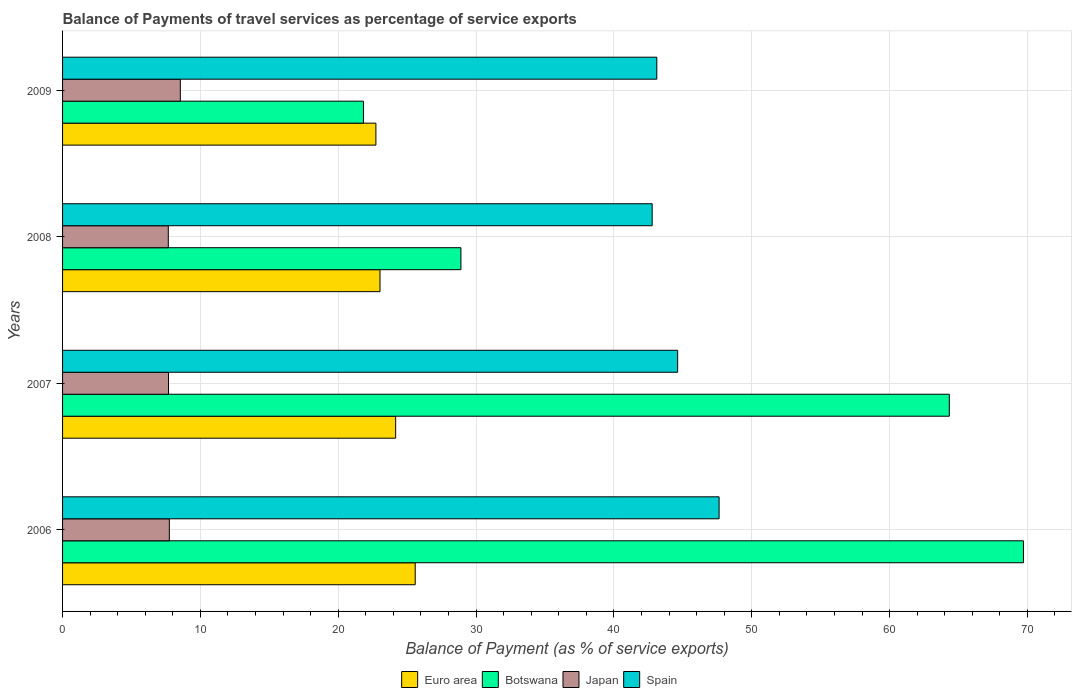How many different coloured bars are there?
Offer a very short reply. 4. Are the number of bars per tick equal to the number of legend labels?
Make the answer very short. Yes. Are the number of bars on each tick of the Y-axis equal?
Offer a very short reply. Yes. What is the label of the 2nd group of bars from the top?
Ensure brevity in your answer.  2008. What is the balance of payments of travel services in Spain in 2007?
Your answer should be very brief. 44.62. Across all years, what is the maximum balance of payments of travel services in Botswana?
Ensure brevity in your answer.  69.71. Across all years, what is the minimum balance of payments of travel services in Spain?
Offer a terse response. 42.78. In which year was the balance of payments of travel services in Spain minimum?
Provide a succinct answer. 2008. What is the total balance of payments of travel services in Euro area in the graph?
Provide a succinct answer. 95.51. What is the difference between the balance of payments of travel services in Spain in 2006 and that in 2009?
Provide a succinct answer. 4.52. What is the difference between the balance of payments of travel services in Japan in 2006 and the balance of payments of travel services in Euro area in 2009?
Make the answer very short. -14.99. What is the average balance of payments of travel services in Japan per year?
Ensure brevity in your answer.  7.91. In the year 2007, what is the difference between the balance of payments of travel services in Spain and balance of payments of travel services in Botswana?
Give a very brief answer. -19.71. In how many years, is the balance of payments of travel services in Spain greater than 58 %?
Keep it short and to the point. 0. What is the ratio of the balance of payments of travel services in Japan in 2006 to that in 2009?
Keep it short and to the point. 0.91. Is the balance of payments of travel services in Botswana in 2007 less than that in 2009?
Offer a terse response. No. What is the difference between the highest and the second highest balance of payments of travel services in Euro area?
Keep it short and to the point. 1.42. What is the difference between the highest and the lowest balance of payments of travel services in Botswana?
Keep it short and to the point. 47.88. In how many years, is the balance of payments of travel services in Spain greater than the average balance of payments of travel services in Spain taken over all years?
Keep it short and to the point. 2. Is the sum of the balance of payments of travel services in Japan in 2008 and 2009 greater than the maximum balance of payments of travel services in Euro area across all years?
Keep it short and to the point. No. What does the 2nd bar from the top in 2009 represents?
Provide a succinct answer. Japan. Is it the case that in every year, the sum of the balance of payments of travel services in Euro area and balance of payments of travel services in Japan is greater than the balance of payments of travel services in Spain?
Give a very brief answer. No. What is the difference between two consecutive major ticks on the X-axis?
Provide a succinct answer. 10. Are the values on the major ticks of X-axis written in scientific E-notation?
Make the answer very short. No. Does the graph contain any zero values?
Provide a short and direct response. No. Does the graph contain grids?
Offer a very short reply. Yes. How many legend labels are there?
Make the answer very short. 4. What is the title of the graph?
Make the answer very short. Balance of Payments of travel services as percentage of service exports. What is the label or title of the X-axis?
Give a very brief answer. Balance of Payment (as % of service exports). What is the Balance of Payment (as % of service exports) of Euro area in 2006?
Your response must be concise. 25.58. What is the Balance of Payment (as % of service exports) of Botswana in 2006?
Give a very brief answer. 69.71. What is the Balance of Payment (as % of service exports) in Japan in 2006?
Ensure brevity in your answer.  7.75. What is the Balance of Payment (as % of service exports) in Spain in 2006?
Offer a terse response. 47.63. What is the Balance of Payment (as % of service exports) of Euro area in 2007?
Offer a terse response. 24.17. What is the Balance of Payment (as % of service exports) in Botswana in 2007?
Ensure brevity in your answer.  64.33. What is the Balance of Payment (as % of service exports) in Japan in 2007?
Keep it short and to the point. 7.69. What is the Balance of Payment (as % of service exports) in Spain in 2007?
Your response must be concise. 44.62. What is the Balance of Payment (as % of service exports) of Euro area in 2008?
Your response must be concise. 23.03. What is the Balance of Payment (as % of service exports) of Botswana in 2008?
Give a very brief answer. 28.9. What is the Balance of Payment (as % of service exports) of Japan in 2008?
Your response must be concise. 7.67. What is the Balance of Payment (as % of service exports) in Spain in 2008?
Keep it short and to the point. 42.78. What is the Balance of Payment (as % of service exports) in Euro area in 2009?
Give a very brief answer. 22.73. What is the Balance of Payment (as % of service exports) of Botswana in 2009?
Your answer should be compact. 21.83. What is the Balance of Payment (as % of service exports) of Japan in 2009?
Ensure brevity in your answer.  8.54. What is the Balance of Payment (as % of service exports) in Spain in 2009?
Provide a succinct answer. 43.11. Across all years, what is the maximum Balance of Payment (as % of service exports) of Euro area?
Ensure brevity in your answer.  25.58. Across all years, what is the maximum Balance of Payment (as % of service exports) of Botswana?
Offer a terse response. 69.71. Across all years, what is the maximum Balance of Payment (as % of service exports) in Japan?
Keep it short and to the point. 8.54. Across all years, what is the maximum Balance of Payment (as % of service exports) in Spain?
Provide a succinct answer. 47.63. Across all years, what is the minimum Balance of Payment (as % of service exports) of Euro area?
Ensure brevity in your answer.  22.73. Across all years, what is the minimum Balance of Payment (as % of service exports) of Botswana?
Make the answer very short. 21.83. Across all years, what is the minimum Balance of Payment (as % of service exports) in Japan?
Make the answer very short. 7.67. Across all years, what is the minimum Balance of Payment (as % of service exports) in Spain?
Your answer should be compact. 42.78. What is the total Balance of Payment (as % of service exports) in Euro area in the graph?
Provide a succinct answer. 95.51. What is the total Balance of Payment (as % of service exports) in Botswana in the graph?
Your answer should be very brief. 184.78. What is the total Balance of Payment (as % of service exports) of Japan in the graph?
Make the answer very short. 31.65. What is the total Balance of Payment (as % of service exports) in Spain in the graph?
Give a very brief answer. 178.14. What is the difference between the Balance of Payment (as % of service exports) in Euro area in 2006 and that in 2007?
Keep it short and to the point. 1.42. What is the difference between the Balance of Payment (as % of service exports) of Botswana in 2006 and that in 2007?
Make the answer very short. 5.38. What is the difference between the Balance of Payment (as % of service exports) in Japan in 2006 and that in 2007?
Your response must be concise. 0.06. What is the difference between the Balance of Payment (as % of service exports) in Spain in 2006 and that in 2007?
Keep it short and to the point. 3.01. What is the difference between the Balance of Payment (as % of service exports) of Euro area in 2006 and that in 2008?
Make the answer very short. 2.55. What is the difference between the Balance of Payment (as % of service exports) in Botswana in 2006 and that in 2008?
Give a very brief answer. 40.81. What is the difference between the Balance of Payment (as % of service exports) of Japan in 2006 and that in 2008?
Your answer should be very brief. 0.07. What is the difference between the Balance of Payment (as % of service exports) in Spain in 2006 and that in 2008?
Keep it short and to the point. 4.86. What is the difference between the Balance of Payment (as % of service exports) in Euro area in 2006 and that in 2009?
Your answer should be compact. 2.85. What is the difference between the Balance of Payment (as % of service exports) of Botswana in 2006 and that in 2009?
Offer a terse response. 47.88. What is the difference between the Balance of Payment (as % of service exports) of Japan in 2006 and that in 2009?
Ensure brevity in your answer.  -0.8. What is the difference between the Balance of Payment (as % of service exports) of Spain in 2006 and that in 2009?
Your answer should be compact. 4.52. What is the difference between the Balance of Payment (as % of service exports) in Euro area in 2007 and that in 2008?
Offer a very short reply. 1.14. What is the difference between the Balance of Payment (as % of service exports) in Botswana in 2007 and that in 2008?
Provide a short and direct response. 35.43. What is the difference between the Balance of Payment (as % of service exports) in Japan in 2007 and that in 2008?
Your answer should be compact. 0.02. What is the difference between the Balance of Payment (as % of service exports) in Spain in 2007 and that in 2008?
Offer a very short reply. 1.85. What is the difference between the Balance of Payment (as % of service exports) of Euro area in 2007 and that in 2009?
Offer a very short reply. 1.43. What is the difference between the Balance of Payment (as % of service exports) in Botswana in 2007 and that in 2009?
Give a very brief answer. 42.5. What is the difference between the Balance of Payment (as % of service exports) of Japan in 2007 and that in 2009?
Give a very brief answer. -0.86. What is the difference between the Balance of Payment (as % of service exports) of Spain in 2007 and that in 2009?
Provide a succinct answer. 1.51. What is the difference between the Balance of Payment (as % of service exports) of Euro area in 2008 and that in 2009?
Keep it short and to the point. 0.3. What is the difference between the Balance of Payment (as % of service exports) of Botswana in 2008 and that in 2009?
Offer a terse response. 7.07. What is the difference between the Balance of Payment (as % of service exports) in Japan in 2008 and that in 2009?
Ensure brevity in your answer.  -0.87. What is the difference between the Balance of Payment (as % of service exports) of Spain in 2008 and that in 2009?
Ensure brevity in your answer.  -0.34. What is the difference between the Balance of Payment (as % of service exports) in Euro area in 2006 and the Balance of Payment (as % of service exports) in Botswana in 2007?
Offer a very short reply. -38.75. What is the difference between the Balance of Payment (as % of service exports) in Euro area in 2006 and the Balance of Payment (as % of service exports) in Japan in 2007?
Your response must be concise. 17.9. What is the difference between the Balance of Payment (as % of service exports) in Euro area in 2006 and the Balance of Payment (as % of service exports) in Spain in 2007?
Provide a succinct answer. -19.04. What is the difference between the Balance of Payment (as % of service exports) in Botswana in 2006 and the Balance of Payment (as % of service exports) in Japan in 2007?
Your response must be concise. 62.03. What is the difference between the Balance of Payment (as % of service exports) of Botswana in 2006 and the Balance of Payment (as % of service exports) of Spain in 2007?
Your answer should be very brief. 25.09. What is the difference between the Balance of Payment (as % of service exports) in Japan in 2006 and the Balance of Payment (as % of service exports) in Spain in 2007?
Offer a terse response. -36.88. What is the difference between the Balance of Payment (as % of service exports) in Euro area in 2006 and the Balance of Payment (as % of service exports) in Botswana in 2008?
Provide a succinct answer. -3.32. What is the difference between the Balance of Payment (as % of service exports) of Euro area in 2006 and the Balance of Payment (as % of service exports) of Japan in 2008?
Your response must be concise. 17.91. What is the difference between the Balance of Payment (as % of service exports) in Euro area in 2006 and the Balance of Payment (as % of service exports) in Spain in 2008?
Provide a succinct answer. -17.19. What is the difference between the Balance of Payment (as % of service exports) of Botswana in 2006 and the Balance of Payment (as % of service exports) of Japan in 2008?
Provide a succinct answer. 62.04. What is the difference between the Balance of Payment (as % of service exports) of Botswana in 2006 and the Balance of Payment (as % of service exports) of Spain in 2008?
Keep it short and to the point. 26.94. What is the difference between the Balance of Payment (as % of service exports) of Japan in 2006 and the Balance of Payment (as % of service exports) of Spain in 2008?
Your answer should be very brief. -35.03. What is the difference between the Balance of Payment (as % of service exports) in Euro area in 2006 and the Balance of Payment (as % of service exports) in Botswana in 2009?
Your answer should be compact. 3.76. What is the difference between the Balance of Payment (as % of service exports) in Euro area in 2006 and the Balance of Payment (as % of service exports) in Japan in 2009?
Give a very brief answer. 17.04. What is the difference between the Balance of Payment (as % of service exports) in Euro area in 2006 and the Balance of Payment (as % of service exports) in Spain in 2009?
Your answer should be compact. -17.53. What is the difference between the Balance of Payment (as % of service exports) of Botswana in 2006 and the Balance of Payment (as % of service exports) of Japan in 2009?
Offer a very short reply. 61.17. What is the difference between the Balance of Payment (as % of service exports) of Botswana in 2006 and the Balance of Payment (as % of service exports) of Spain in 2009?
Your answer should be compact. 26.6. What is the difference between the Balance of Payment (as % of service exports) of Japan in 2006 and the Balance of Payment (as % of service exports) of Spain in 2009?
Make the answer very short. -35.37. What is the difference between the Balance of Payment (as % of service exports) in Euro area in 2007 and the Balance of Payment (as % of service exports) in Botswana in 2008?
Your answer should be very brief. -4.74. What is the difference between the Balance of Payment (as % of service exports) of Euro area in 2007 and the Balance of Payment (as % of service exports) of Japan in 2008?
Offer a very short reply. 16.49. What is the difference between the Balance of Payment (as % of service exports) in Euro area in 2007 and the Balance of Payment (as % of service exports) in Spain in 2008?
Ensure brevity in your answer.  -18.61. What is the difference between the Balance of Payment (as % of service exports) of Botswana in 2007 and the Balance of Payment (as % of service exports) of Japan in 2008?
Your answer should be compact. 56.66. What is the difference between the Balance of Payment (as % of service exports) of Botswana in 2007 and the Balance of Payment (as % of service exports) of Spain in 2008?
Provide a succinct answer. 21.56. What is the difference between the Balance of Payment (as % of service exports) of Japan in 2007 and the Balance of Payment (as % of service exports) of Spain in 2008?
Give a very brief answer. -35.09. What is the difference between the Balance of Payment (as % of service exports) in Euro area in 2007 and the Balance of Payment (as % of service exports) in Botswana in 2009?
Offer a very short reply. 2.34. What is the difference between the Balance of Payment (as % of service exports) of Euro area in 2007 and the Balance of Payment (as % of service exports) of Japan in 2009?
Make the answer very short. 15.62. What is the difference between the Balance of Payment (as % of service exports) in Euro area in 2007 and the Balance of Payment (as % of service exports) in Spain in 2009?
Your answer should be compact. -18.95. What is the difference between the Balance of Payment (as % of service exports) of Botswana in 2007 and the Balance of Payment (as % of service exports) of Japan in 2009?
Your answer should be compact. 55.79. What is the difference between the Balance of Payment (as % of service exports) of Botswana in 2007 and the Balance of Payment (as % of service exports) of Spain in 2009?
Ensure brevity in your answer.  21.22. What is the difference between the Balance of Payment (as % of service exports) in Japan in 2007 and the Balance of Payment (as % of service exports) in Spain in 2009?
Provide a succinct answer. -35.43. What is the difference between the Balance of Payment (as % of service exports) of Euro area in 2008 and the Balance of Payment (as % of service exports) of Botswana in 2009?
Your response must be concise. 1.2. What is the difference between the Balance of Payment (as % of service exports) in Euro area in 2008 and the Balance of Payment (as % of service exports) in Japan in 2009?
Give a very brief answer. 14.49. What is the difference between the Balance of Payment (as % of service exports) in Euro area in 2008 and the Balance of Payment (as % of service exports) in Spain in 2009?
Make the answer very short. -20.08. What is the difference between the Balance of Payment (as % of service exports) of Botswana in 2008 and the Balance of Payment (as % of service exports) of Japan in 2009?
Your response must be concise. 20.36. What is the difference between the Balance of Payment (as % of service exports) of Botswana in 2008 and the Balance of Payment (as % of service exports) of Spain in 2009?
Provide a succinct answer. -14.21. What is the difference between the Balance of Payment (as % of service exports) of Japan in 2008 and the Balance of Payment (as % of service exports) of Spain in 2009?
Offer a terse response. -35.44. What is the average Balance of Payment (as % of service exports) of Euro area per year?
Provide a short and direct response. 23.88. What is the average Balance of Payment (as % of service exports) of Botswana per year?
Provide a succinct answer. 46.19. What is the average Balance of Payment (as % of service exports) of Japan per year?
Make the answer very short. 7.91. What is the average Balance of Payment (as % of service exports) of Spain per year?
Provide a short and direct response. 44.54. In the year 2006, what is the difference between the Balance of Payment (as % of service exports) in Euro area and Balance of Payment (as % of service exports) in Botswana?
Your answer should be very brief. -44.13. In the year 2006, what is the difference between the Balance of Payment (as % of service exports) of Euro area and Balance of Payment (as % of service exports) of Japan?
Give a very brief answer. 17.84. In the year 2006, what is the difference between the Balance of Payment (as % of service exports) in Euro area and Balance of Payment (as % of service exports) in Spain?
Your answer should be compact. -22.05. In the year 2006, what is the difference between the Balance of Payment (as % of service exports) in Botswana and Balance of Payment (as % of service exports) in Japan?
Provide a succinct answer. 61.97. In the year 2006, what is the difference between the Balance of Payment (as % of service exports) in Botswana and Balance of Payment (as % of service exports) in Spain?
Your response must be concise. 22.08. In the year 2006, what is the difference between the Balance of Payment (as % of service exports) of Japan and Balance of Payment (as % of service exports) of Spain?
Give a very brief answer. -39.88. In the year 2007, what is the difference between the Balance of Payment (as % of service exports) of Euro area and Balance of Payment (as % of service exports) of Botswana?
Keep it short and to the point. -40.17. In the year 2007, what is the difference between the Balance of Payment (as % of service exports) of Euro area and Balance of Payment (as % of service exports) of Japan?
Give a very brief answer. 16.48. In the year 2007, what is the difference between the Balance of Payment (as % of service exports) in Euro area and Balance of Payment (as % of service exports) in Spain?
Provide a short and direct response. -20.46. In the year 2007, what is the difference between the Balance of Payment (as % of service exports) of Botswana and Balance of Payment (as % of service exports) of Japan?
Your response must be concise. 56.65. In the year 2007, what is the difference between the Balance of Payment (as % of service exports) of Botswana and Balance of Payment (as % of service exports) of Spain?
Keep it short and to the point. 19.71. In the year 2007, what is the difference between the Balance of Payment (as % of service exports) in Japan and Balance of Payment (as % of service exports) in Spain?
Provide a succinct answer. -36.94. In the year 2008, what is the difference between the Balance of Payment (as % of service exports) of Euro area and Balance of Payment (as % of service exports) of Botswana?
Ensure brevity in your answer.  -5.87. In the year 2008, what is the difference between the Balance of Payment (as % of service exports) of Euro area and Balance of Payment (as % of service exports) of Japan?
Offer a terse response. 15.36. In the year 2008, what is the difference between the Balance of Payment (as % of service exports) in Euro area and Balance of Payment (as % of service exports) in Spain?
Provide a succinct answer. -19.75. In the year 2008, what is the difference between the Balance of Payment (as % of service exports) in Botswana and Balance of Payment (as % of service exports) in Japan?
Ensure brevity in your answer.  21.23. In the year 2008, what is the difference between the Balance of Payment (as % of service exports) in Botswana and Balance of Payment (as % of service exports) in Spain?
Make the answer very short. -13.87. In the year 2008, what is the difference between the Balance of Payment (as % of service exports) in Japan and Balance of Payment (as % of service exports) in Spain?
Give a very brief answer. -35.1. In the year 2009, what is the difference between the Balance of Payment (as % of service exports) in Euro area and Balance of Payment (as % of service exports) in Botswana?
Offer a terse response. 0.9. In the year 2009, what is the difference between the Balance of Payment (as % of service exports) of Euro area and Balance of Payment (as % of service exports) of Japan?
Your response must be concise. 14.19. In the year 2009, what is the difference between the Balance of Payment (as % of service exports) of Euro area and Balance of Payment (as % of service exports) of Spain?
Provide a succinct answer. -20.38. In the year 2009, what is the difference between the Balance of Payment (as % of service exports) of Botswana and Balance of Payment (as % of service exports) of Japan?
Offer a very short reply. 13.29. In the year 2009, what is the difference between the Balance of Payment (as % of service exports) of Botswana and Balance of Payment (as % of service exports) of Spain?
Make the answer very short. -21.28. In the year 2009, what is the difference between the Balance of Payment (as % of service exports) in Japan and Balance of Payment (as % of service exports) in Spain?
Your answer should be very brief. -34.57. What is the ratio of the Balance of Payment (as % of service exports) of Euro area in 2006 to that in 2007?
Make the answer very short. 1.06. What is the ratio of the Balance of Payment (as % of service exports) in Botswana in 2006 to that in 2007?
Ensure brevity in your answer.  1.08. What is the ratio of the Balance of Payment (as % of service exports) in Japan in 2006 to that in 2007?
Ensure brevity in your answer.  1.01. What is the ratio of the Balance of Payment (as % of service exports) in Spain in 2006 to that in 2007?
Provide a short and direct response. 1.07. What is the ratio of the Balance of Payment (as % of service exports) of Euro area in 2006 to that in 2008?
Offer a terse response. 1.11. What is the ratio of the Balance of Payment (as % of service exports) of Botswana in 2006 to that in 2008?
Offer a terse response. 2.41. What is the ratio of the Balance of Payment (as % of service exports) in Japan in 2006 to that in 2008?
Make the answer very short. 1.01. What is the ratio of the Balance of Payment (as % of service exports) of Spain in 2006 to that in 2008?
Your response must be concise. 1.11. What is the ratio of the Balance of Payment (as % of service exports) of Euro area in 2006 to that in 2009?
Your response must be concise. 1.13. What is the ratio of the Balance of Payment (as % of service exports) in Botswana in 2006 to that in 2009?
Give a very brief answer. 3.19. What is the ratio of the Balance of Payment (as % of service exports) of Japan in 2006 to that in 2009?
Provide a short and direct response. 0.91. What is the ratio of the Balance of Payment (as % of service exports) of Spain in 2006 to that in 2009?
Keep it short and to the point. 1.1. What is the ratio of the Balance of Payment (as % of service exports) of Euro area in 2007 to that in 2008?
Your answer should be compact. 1.05. What is the ratio of the Balance of Payment (as % of service exports) in Botswana in 2007 to that in 2008?
Your response must be concise. 2.23. What is the ratio of the Balance of Payment (as % of service exports) in Spain in 2007 to that in 2008?
Keep it short and to the point. 1.04. What is the ratio of the Balance of Payment (as % of service exports) in Euro area in 2007 to that in 2009?
Your answer should be compact. 1.06. What is the ratio of the Balance of Payment (as % of service exports) of Botswana in 2007 to that in 2009?
Make the answer very short. 2.95. What is the ratio of the Balance of Payment (as % of service exports) in Japan in 2007 to that in 2009?
Ensure brevity in your answer.  0.9. What is the ratio of the Balance of Payment (as % of service exports) of Spain in 2007 to that in 2009?
Provide a short and direct response. 1.03. What is the ratio of the Balance of Payment (as % of service exports) in Euro area in 2008 to that in 2009?
Give a very brief answer. 1.01. What is the ratio of the Balance of Payment (as % of service exports) of Botswana in 2008 to that in 2009?
Make the answer very short. 1.32. What is the ratio of the Balance of Payment (as % of service exports) of Japan in 2008 to that in 2009?
Provide a short and direct response. 0.9. What is the ratio of the Balance of Payment (as % of service exports) of Spain in 2008 to that in 2009?
Provide a short and direct response. 0.99. What is the difference between the highest and the second highest Balance of Payment (as % of service exports) of Euro area?
Keep it short and to the point. 1.42. What is the difference between the highest and the second highest Balance of Payment (as % of service exports) of Botswana?
Make the answer very short. 5.38. What is the difference between the highest and the second highest Balance of Payment (as % of service exports) of Japan?
Provide a short and direct response. 0.8. What is the difference between the highest and the second highest Balance of Payment (as % of service exports) in Spain?
Your answer should be compact. 3.01. What is the difference between the highest and the lowest Balance of Payment (as % of service exports) in Euro area?
Provide a short and direct response. 2.85. What is the difference between the highest and the lowest Balance of Payment (as % of service exports) of Botswana?
Provide a short and direct response. 47.88. What is the difference between the highest and the lowest Balance of Payment (as % of service exports) of Japan?
Your answer should be compact. 0.87. What is the difference between the highest and the lowest Balance of Payment (as % of service exports) in Spain?
Provide a short and direct response. 4.86. 